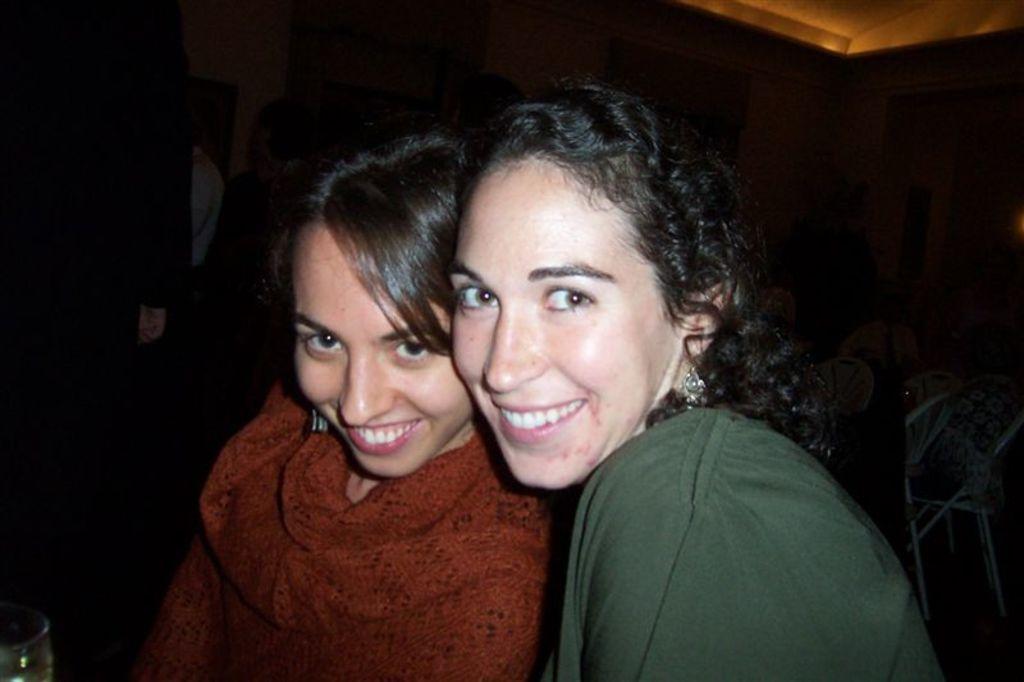Could you give a brief overview of what you see in this image? In the picture I can see a woman wearing a green color dress and a woman wearing maroon color dress are smiling. The background of the image is dark. 